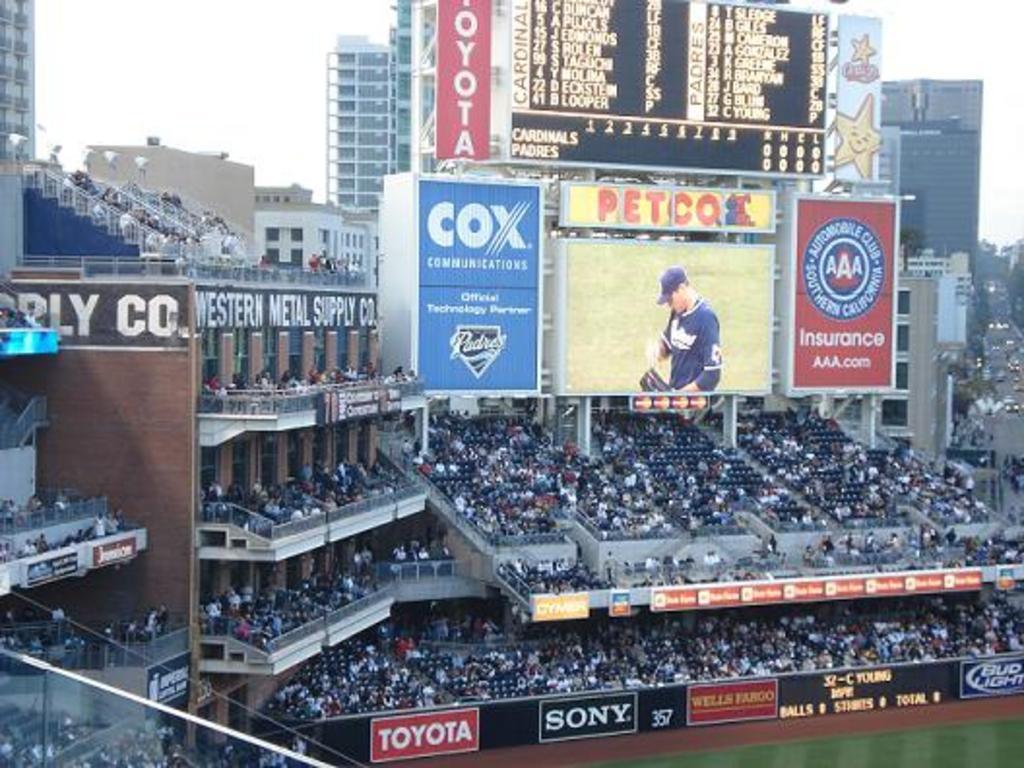Describe this image in one or two sentences. In this image we can see buildings, information boards, display screen, iron grills and spectators. In addition to this we can see sky and ground. 